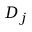<formula> <loc_0><loc_0><loc_500><loc_500>D _ { j }</formula> 